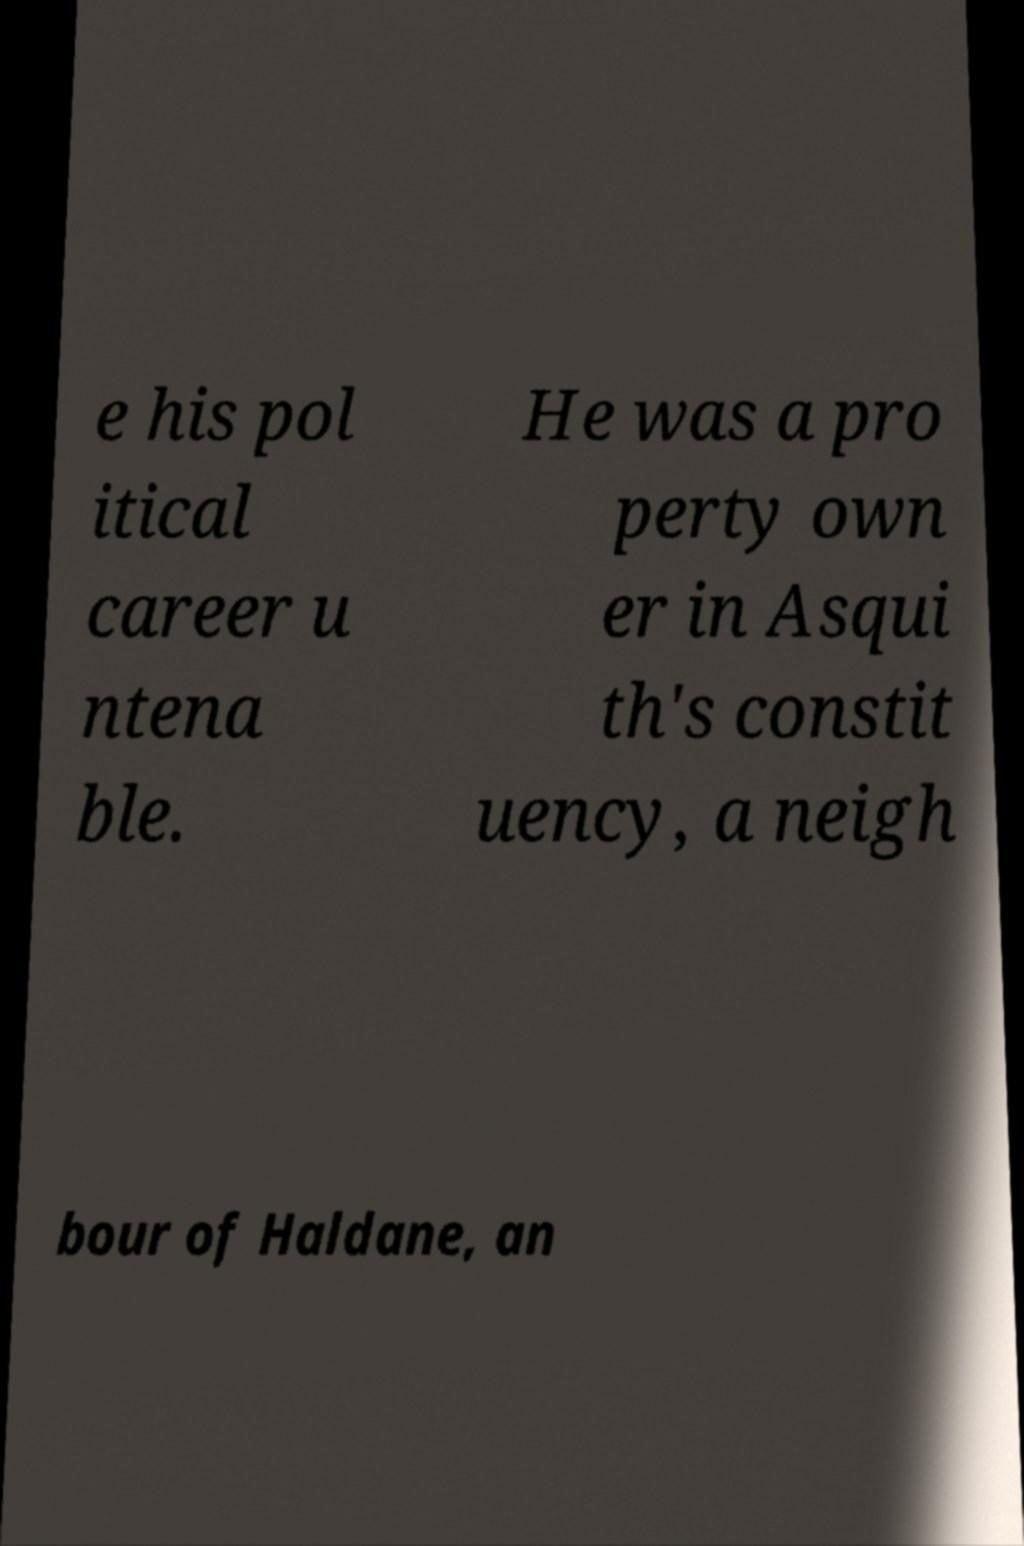What messages or text are displayed in this image? I need them in a readable, typed format. e his pol itical career u ntena ble. He was a pro perty own er in Asqui th's constit uency, a neigh bour of Haldane, an 